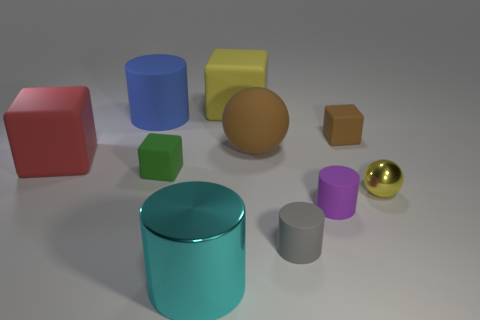Subtract all balls. How many objects are left? 8 Add 3 brown cubes. How many brown cubes are left? 4 Add 2 yellow matte objects. How many yellow matte objects exist? 3 Subtract 1 blue cylinders. How many objects are left? 9 Subtract all gray blocks. Subtract all large brown matte spheres. How many objects are left? 9 